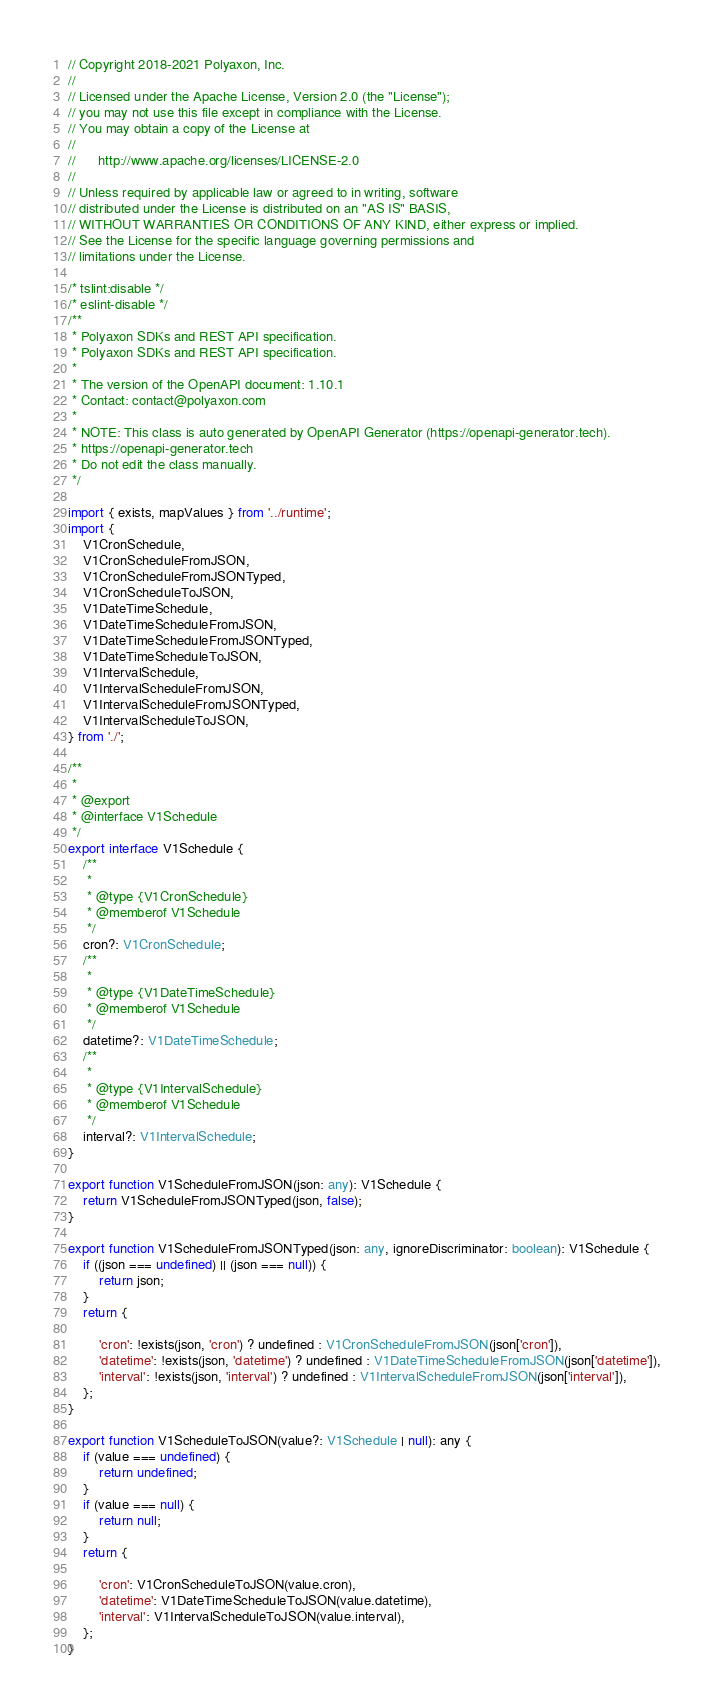Convert code to text. <code><loc_0><loc_0><loc_500><loc_500><_TypeScript_>// Copyright 2018-2021 Polyaxon, Inc.
//
// Licensed under the Apache License, Version 2.0 (the "License");
// you may not use this file except in compliance with the License.
// You may obtain a copy of the License at
//
//      http://www.apache.org/licenses/LICENSE-2.0
//
// Unless required by applicable law or agreed to in writing, software
// distributed under the License is distributed on an "AS IS" BASIS,
// WITHOUT WARRANTIES OR CONDITIONS OF ANY KIND, either express or implied.
// See the License for the specific language governing permissions and
// limitations under the License.

/* tslint:disable */
/* eslint-disable */
/**
 * Polyaxon SDKs and REST API specification.
 * Polyaxon SDKs and REST API specification.
 *
 * The version of the OpenAPI document: 1.10.1
 * Contact: contact@polyaxon.com
 *
 * NOTE: This class is auto generated by OpenAPI Generator (https://openapi-generator.tech).
 * https://openapi-generator.tech
 * Do not edit the class manually.
 */

import { exists, mapValues } from '../runtime';
import {
    V1CronSchedule,
    V1CronScheduleFromJSON,
    V1CronScheduleFromJSONTyped,
    V1CronScheduleToJSON,
    V1DateTimeSchedule,
    V1DateTimeScheduleFromJSON,
    V1DateTimeScheduleFromJSONTyped,
    V1DateTimeScheduleToJSON,
    V1IntervalSchedule,
    V1IntervalScheduleFromJSON,
    V1IntervalScheduleFromJSONTyped,
    V1IntervalScheduleToJSON,
} from './';

/**
 * 
 * @export
 * @interface V1Schedule
 */
export interface V1Schedule {
    /**
     * 
     * @type {V1CronSchedule}
     * @memberof V1Schedule
     */
    cron?: V1CronSchedule;
    /**
     * 
     * @type {V1DateTimeSchedule}
     * @memberof V1Schedule
     */
    datetime?: V1DateTimeSchedule;
    /**
     * 
     * @type {V1IntervalSchedule}
     * @memberof V1Schedule
     */
    interval?: V1IntervalSchedule;
}

export function V1ScheduleFromJSON(json: any): V1Schedule {
    return V1ScheduleFromJSONTyped(json, false);
}

export function V1ScheduleFromJSONTyped(json: any, ignoreDiscriminator: boolean): V1Schedule {
    if ((json === undefined) || (json === null)) {
        return json;
    }
    return {
        
        'cron': !exists(json, 'cron') ? undefined : V1CronScheduleFromJSON(json['cron']),
        'datetime': !exists(json, 'datetime') ? undefined : V1DateTimeScheduleFromJSON(json['datetime']),
        'interval': !exists(json, 'interval') ? undefined : V1IntervalScheduleFromJSON(json['interval']),
    };
}

export function V1ScheduleToJSON(value?: V1Schedule | null): any {
    if (value === undefined) {
        return undefined;
    }
    if (value === null) {
        return null;
    }
    return {
        
        'cron': V1CronScheduleToJSON(value.cron),
        'datetime': V1DateTimeScheduleToJSON(value.datetime),
        'interval': V1IntervalScheduleToJSON(value.interval),
    };
}


</code> 